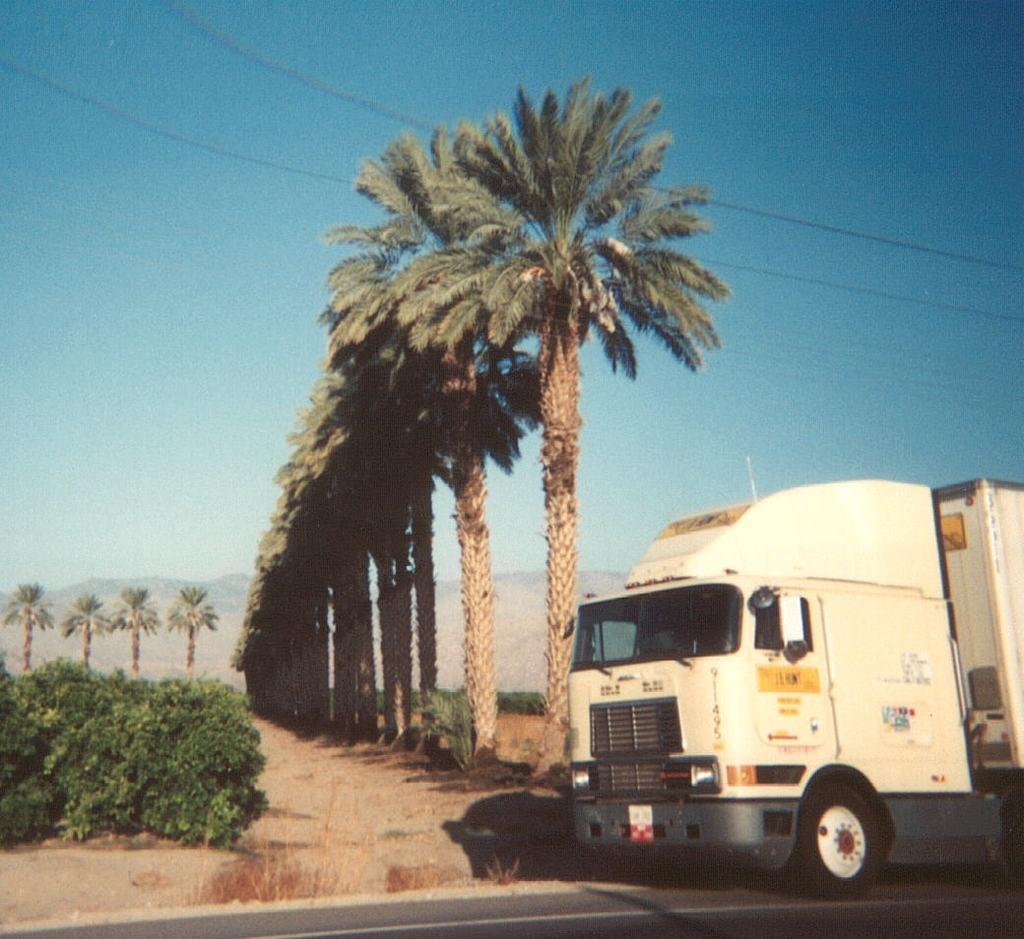What type of vehicle is in the image? There is a white truck in the image. Where is the truck located? The truck is on the road. What can be seen in the background of the image? There are trees, plants, and the sky visible in the background of the image. What else is present in the image? There are wires in the image. Can you see any cobwebs on the truck in the image? There are no cobwebs visible on the truck in the image. Is there a person driving the truck in the image? The image does not show a person driving the truck, only the truck itself. 